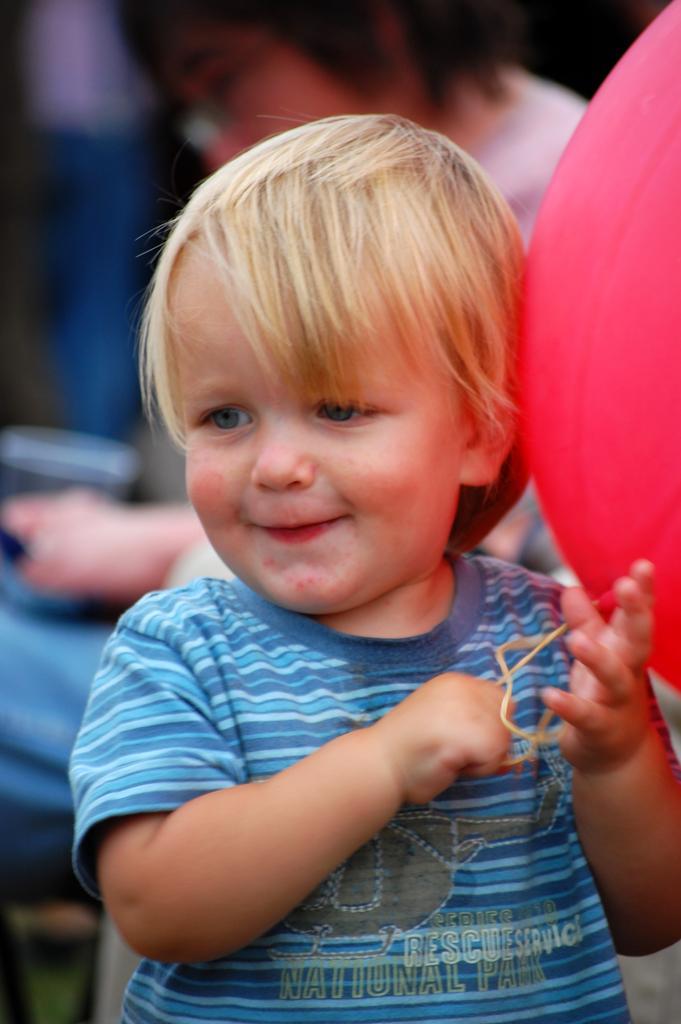What is the person in the foreground holding in the image? The person in the foreground is holding a balloon in the image. What color is the balloon? The balloon is red. Can you describe the person sitting in the background? The person sitting in the background is wearing a blue T-shirt. How does the person holding the balloon rub the balloon against the wall in the image? There is no indication in the image that the person holding the balloon is rubbing it against the wall. 